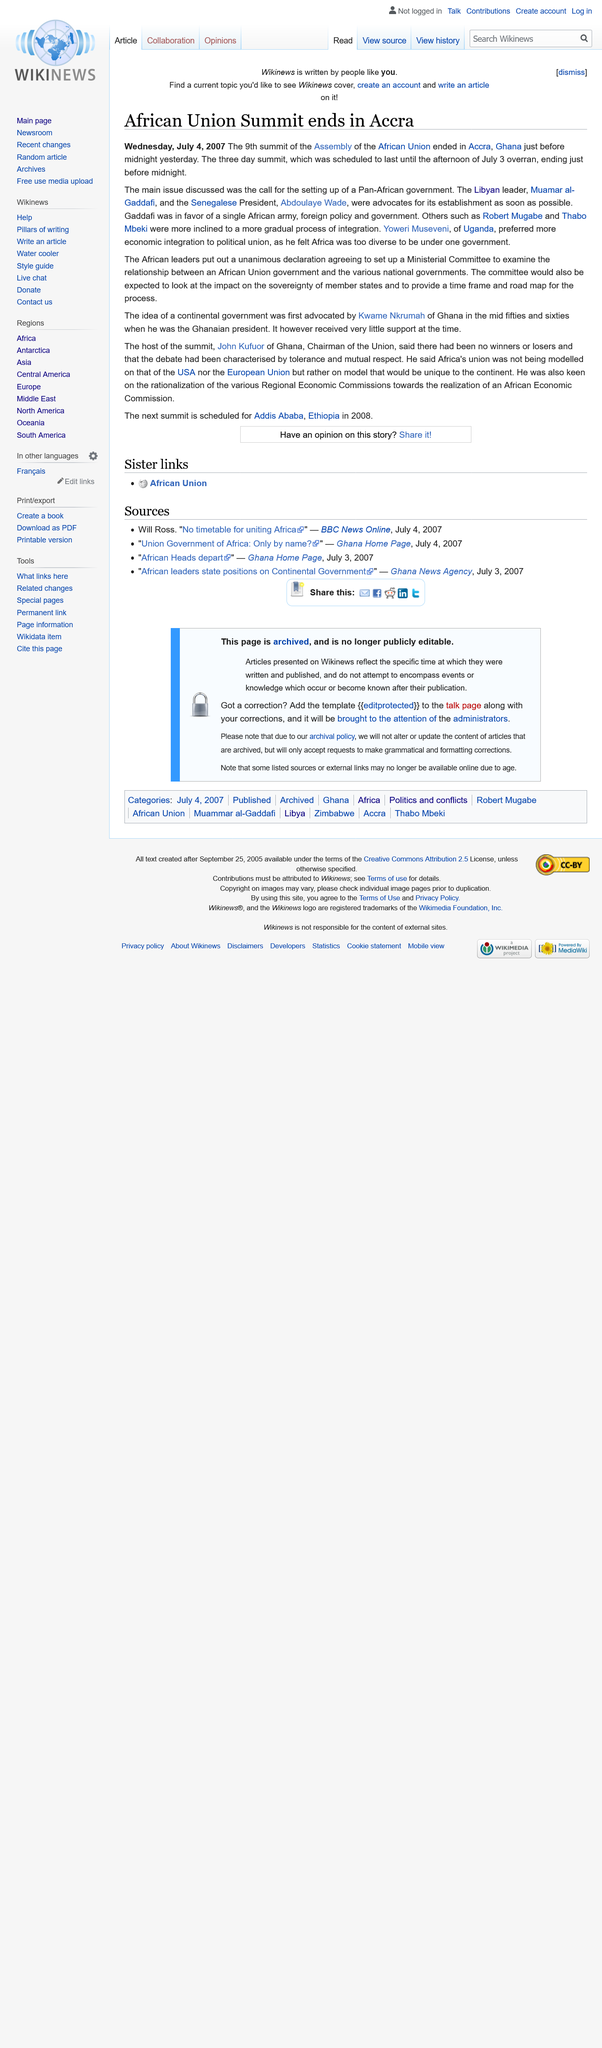Specify some key components in this picture. The 9th summit of the Assembly of the African Union focused on the establishment of a Pan-African government as the primary issue of discussion. Abdoulaye Wade is the current President of Senegal. The 9th summit of the Assembly of the African Union was held in Accra, Ghana, from July 1 to July 2, 2017. 